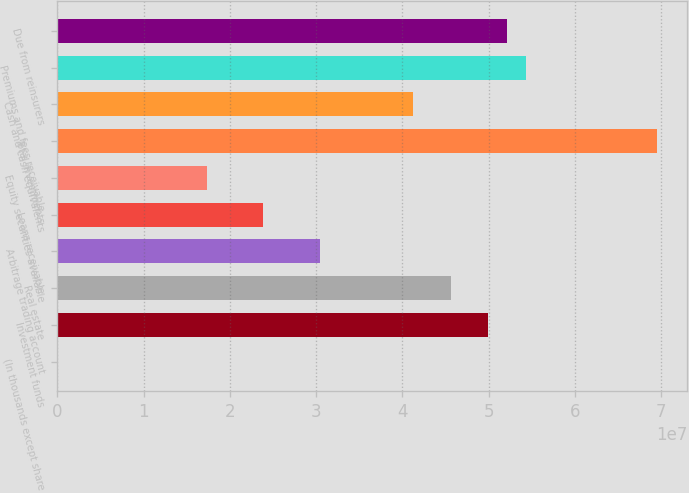<chart> <loc_0><loc_0><loc_500><loc_500><bar_chart><fcel>(In thousands except share<fcel>Investment funds<fcel>Real estate<fcel>Arbitrage trading account<fcel>Loans receivable<fcel>Equity securities available<fcel>Total investments<fcel>Cash and cash equivalents<fcel>Premiums and fees receivable<fcel>Due from reinsurers<nl><fcel>2015<fcel>4.99786e+07<fcel>4.56328e+07<fcel>3.04225e+07<fcel>2.39039e+07<fcel>1.73852e+07<fcel>6.95347e+07<fcel>4.1287e+07<fcel>5.43244e+07<fcel>5.21515e+07<nl></chart> 